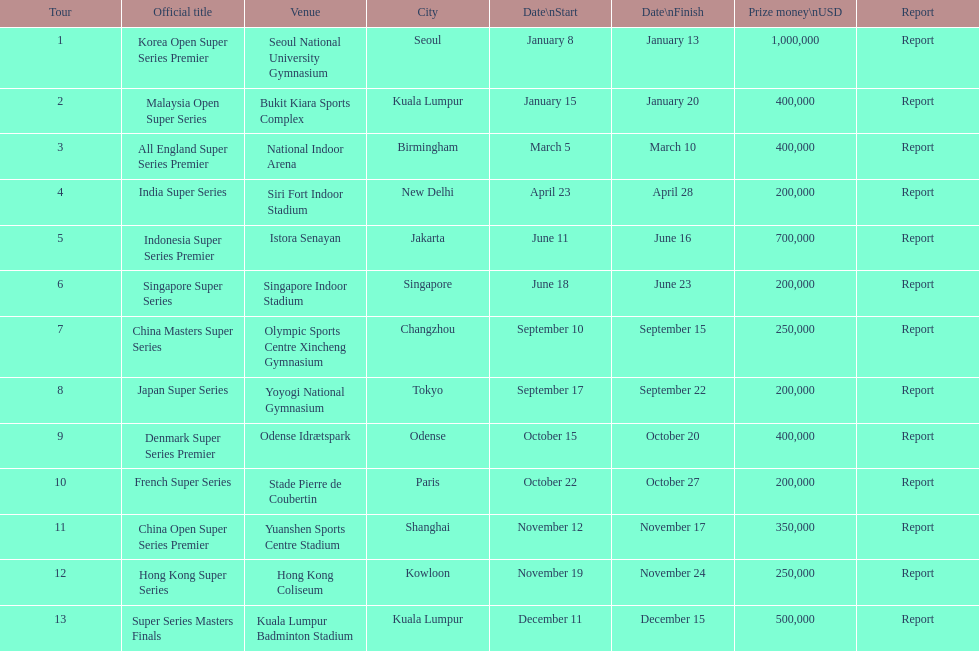How many tours took place during january? 2. 